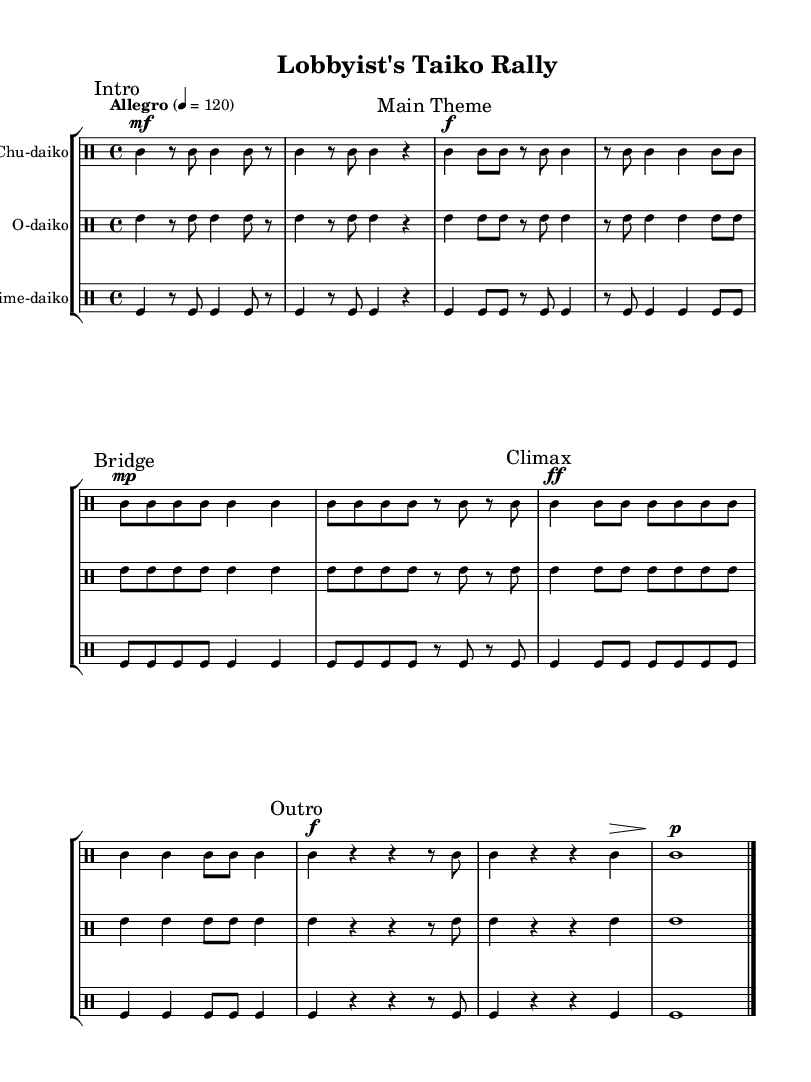What is the time signature of this music? The time signature is indicated at the beginning of the score, represented as 4/4, meaning there are four beats in each measure and a quarter note gets one beat.
Answer: 4/4 What is the tempo marking of this piece? The tempo marking at the beginning states "Allegro" with a metronome marking of 120 beats per minute, indicating a lively and fast pace.
Answer: Allegro How many distinct sections are in this piece? The score is divided into five clearly marked sections: Intro, Main Theme, Bridge, Climax, and Outro. Counting these, we see there are five sections in total.
Answer: 5 Which drum is introduced first in the sheet music? The first drum part indicated in the score is for the Chu-daiko, shown at the start of the written music, followed by O-daiko and Shime-daiko.
Answer: Chu-daiko What dynamic level is indicated for the Climax section? The Climax section has a dynamic marking of "ff," which stands for fortissimo, indicating that this part should be played very loudly.
Answer: ff How many measures are in the Main Theme section? The Main Theme consists of two phrases displayed over four measures; by counting the measures from the section mark, we find a total of eight measures.
Answer: 8 